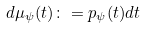Convert formula to latex. <formula><loc_0><loc_0><loc_500><loc_500>d \mu _ { \psi } ( t ) \colon = p _ { \psi } ( t ) d t</formula> 